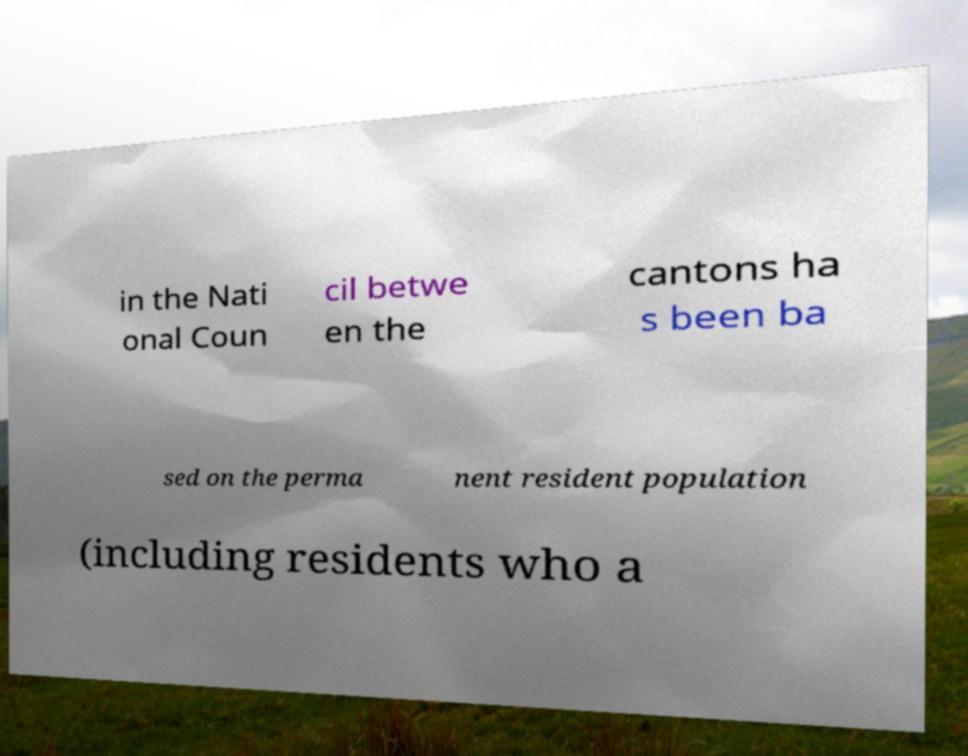There's text embedded in this image that I need extracted. Can you transcribe it verbatim? in the Nati onal Coun cil betwe en the cantons ha s been ba sed on the perma nent resident population (including residents who a 